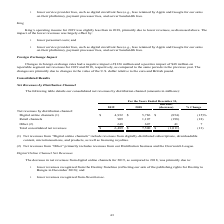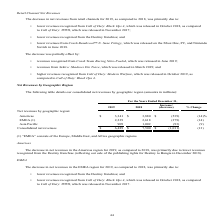According to Activision Blizzard's financial document, What does Net revenues from “Digital online channels” include? revenues from digitally-distributed subscriptions, downloadable content, microtransactions, and products, as well as licensing royalties.. The document states: "et revenues from “Digital online channels” include revenues from digitally-distributed subscriptions, downloadable content, microtransactions, and pro..." Also, What does Net revenues from “Other” include? revenues from our Distribution business and the Overwatch League.. The document states: "(2) Net revenues from “Other” primarily includes revenues from our Distribution business and the Overwatch League...." Also, What was net revenues from retail channels in 2019? According to the financial document, 909 (in millions). The relevant text states: "Retail channels 909 1,107 (198) (18)..." Also, can you calculate: What is the total consolidated net revenue of Digital Online channels and Other in 2019? Based on the calculation: $4,932+648, the result is 5580 (in millions). This is based on the information: "Digital online channels (1) $ 4,932 $ 5,786 $ (854) (15)% Other (2) 648 607 41 7..." The key data points involved are: 4,932, 648. Also, can you calculate: What is the total consolidated net revenue of Digital Online channels and Other in 2018? Based on the calculation: $5,786+607, the result is 6393 (in millions). This is based on the information: "Digital online channels (1) $ 4,932 $ 5,786 $ (854) (15)% Other (2) 648 607 41 7..." The key data points involved are: 5,786, 607. Also, can you calculate: What percentage of total consolidated net revenue consists of Other in 2019? Based on the calculation: (648/$6,489), the result is 9.99 (percentage). This is based on the information: "Total consolidated net revenues $ 6,489 $ 7,500 $ (1,011) (13) Other (2) 648 607 41 7..." The key data points involved are: 6,489, 648. 